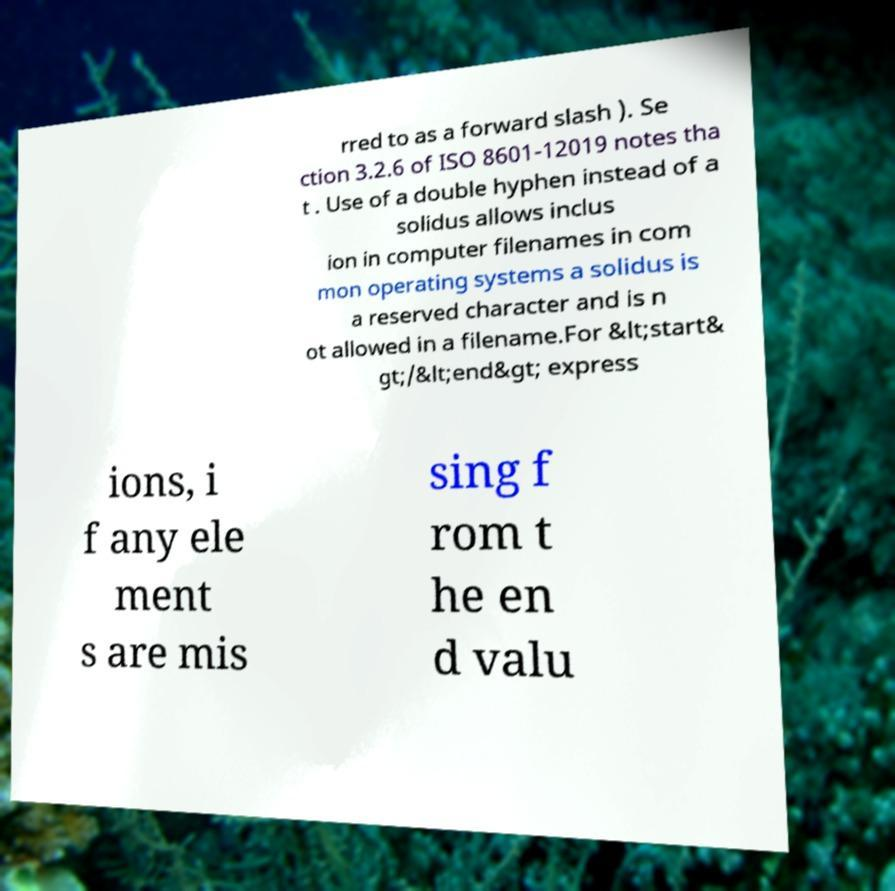Please identify and transcribe the text found in this image. rred to as a forward slash ). Se ction 3.2.6 of ISO 8601-12019 notes tha t . Use of a double hyphen instead of a solidus allows inclus ion in computer filenames in com mon operating systems a solidus is a reserved character and is n ot allowed in a filename.For &lt;start& gt;/&lt;end&gt; express ions, i f any ele ment s are mis sing f rom t he en d valu 